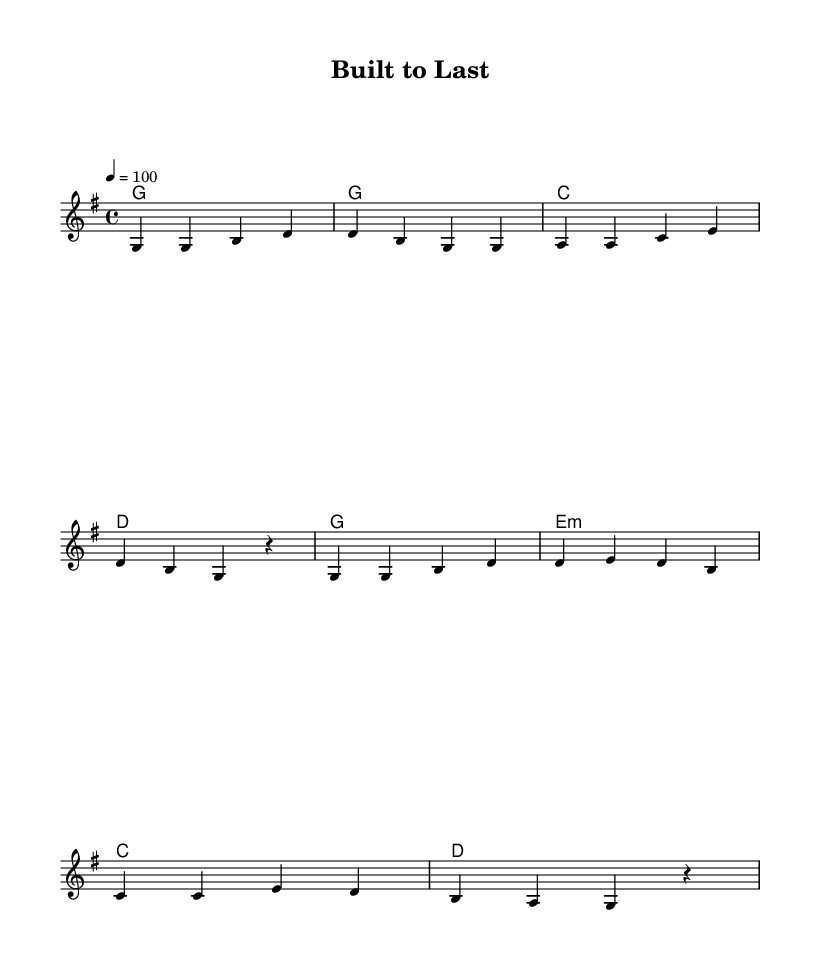What is the key signature of this music? The key signature is G major, which has one sharp (F#).
Answer: G major What is the time signature of this music? The time signature is 4/4, indicating four beats per measure.
Answer: 4/4 What is the tempo marking for this piece? The tempo marking is 100 beats per minute, as indicated by the tempo marking at the beginning of the score.
Answer: 100 How many measures are in the verse section? The verse section has four measures, as counted from the melody section with the repeated rhythmic patterns.
Answer: 4 What is the first chord played in the piece? The first chord is G major, which is indicated in the harmonies section in the first measure.
Answer: G Which line in the lyrics mentions the importance of having quality tools? The line that mentions the importance of having quality tools is "Quality gear makes the job go smooth."
Answer: "Quality gear makes the job go smooth." What is the thematic focus of the chorus in this song? The thematic focus of the chorus highlights the value of quality tools and their ability to effectively complete construction work, as stated in the lyrics.
Answer: Quality tools make our work shine bright 